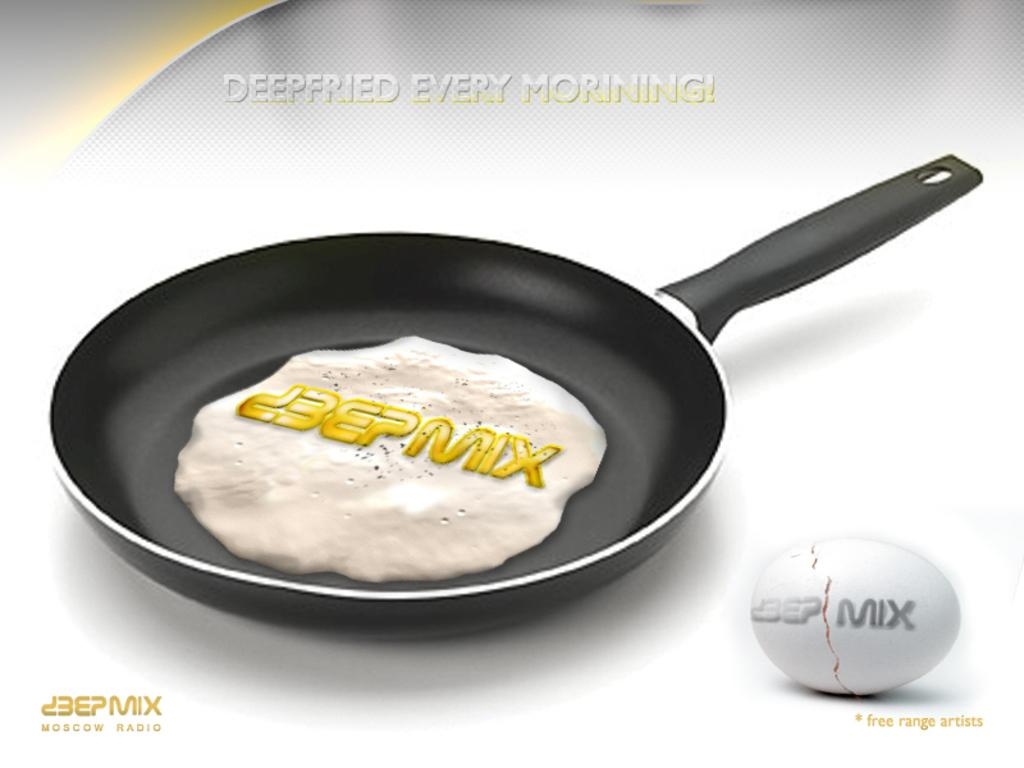What is the main object in the center of the image? There is a pan in the center of the image. What is inside the pan? There is food in the pan. What additional information is provided with the image? There is text associated with the image. What can be seen on the right side of the image? There is an egg on the right side of the image. Where is the table located in the image? There is no table present in the image. What type of dolls can be seen playing with the meat in the image? There is no meat or dolls present in the image. 